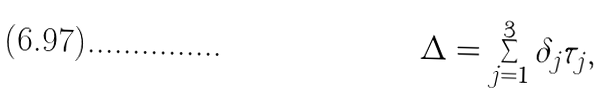<formula> <loc_0><loc_0><loc_500><loc_500>\Delta = \sum _ { j = 1 } ^ { 3 } \delta _ { j } \tau _ { j } ,</formula> 